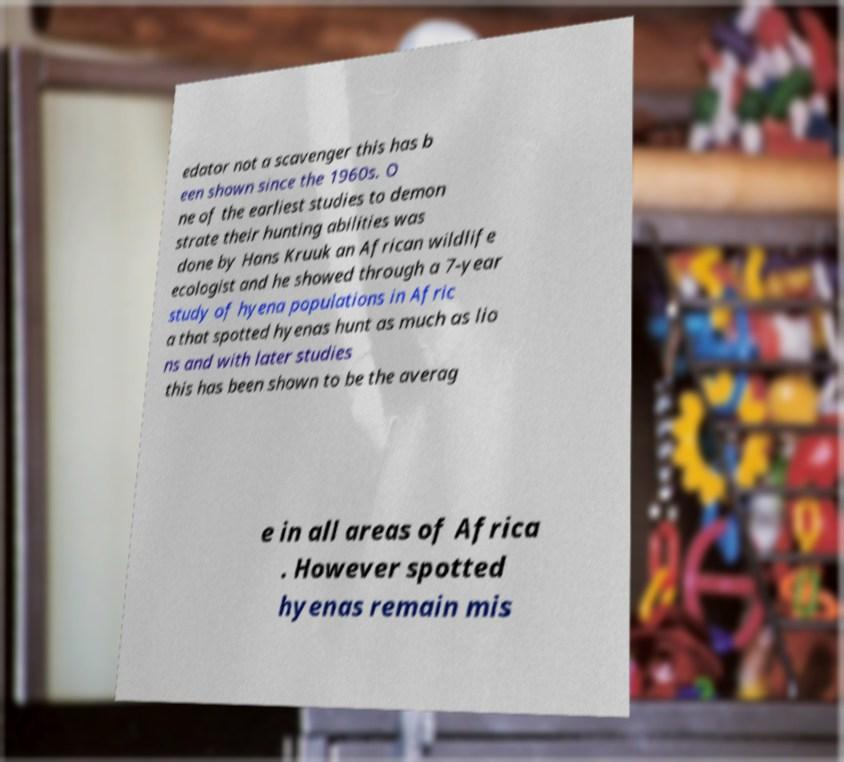Please read and relay the text visible in this image. What does it say? edator not a scavenger this has b een shown since the 1960s. O ne of the earliest studies to demon strate their hunting abilities was done by Hans Kruuk an African wildlife ecologist and he showed through a 7-year study of hyena populations in Afric a that spotted hyenas hunt as much as lio ns and with later studies this has been shown to be the averag e in all areas of Africa . However spotted hyenas remain mis 